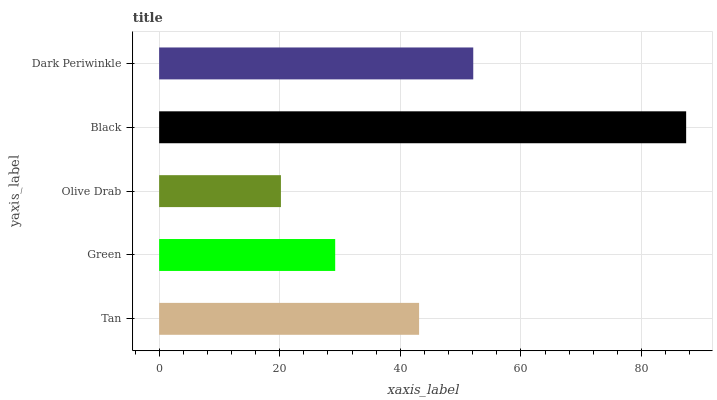Is Olive Drab the minimum?
Answer yes or no. Yes. Is Black the maximum?
Answer yes or no. Yes. Is Green the minimum?
Answer yes or no. No. Is Green the maximum?
Answer yes or no. No. Is Tan greater than Green?
Answer yes or no. Yes. Is Green less than Tan?
Answer yes or no. Yes. Is Green greater than Tan?
Answer yes or no. No. Is Tan less than Green?
Answer yes or no. No. Is Tan the high median?
Answer yes or no. Yes. Is Tan the low median?
Answer yes or no. Yes. Is Black the high median?
Answer yes or no. No. Is Green the low median?
Answer yes or no. No. 